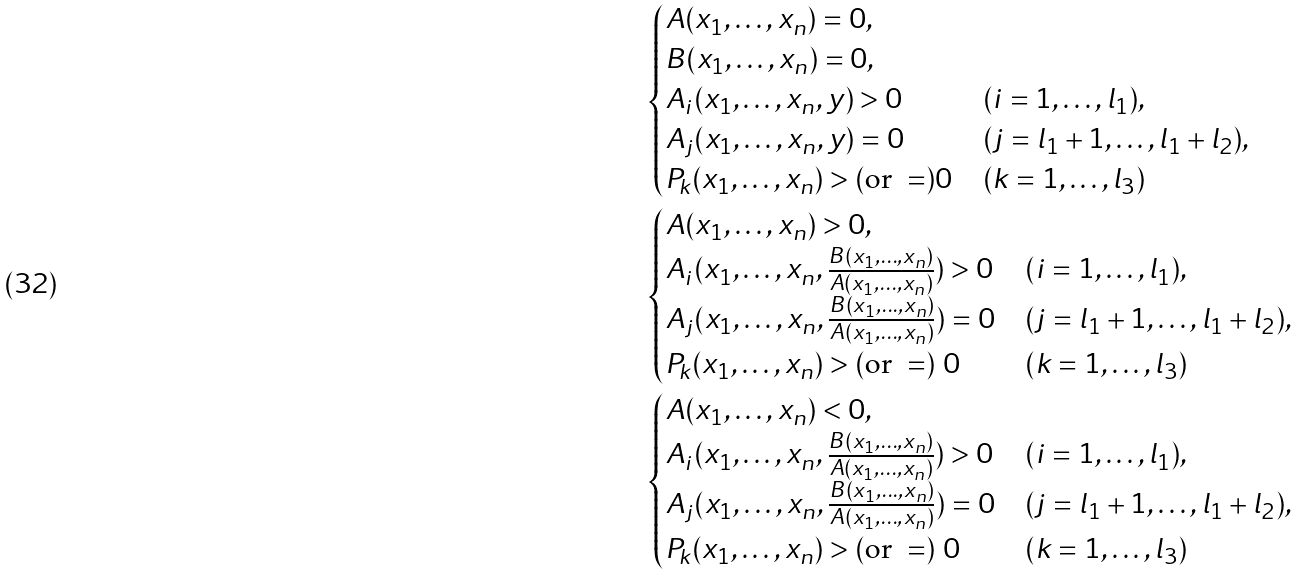Convert formula to latex. <formula><loc_0><loc_0><loc_500><loc_500>& \begin{cases} A ( x _ { 1 } , \dots , x _ { n } ) = 0 , & \\ B ( x _ { 1 } , \dots , x _ { n } ) = 0 , & \\ A _ { i } ( x _ { 1 } , \dots , x _ { n } , y ) > 0 & ( i = 1 , \dots , l _ { 1 } ) , \\ A _ { j } ( x _ { 1 } , \dots , x _ { n } , y ) = 0 & ( j = l _ { 1 } + 1 , \dots , l _ { 1 } + l _ { 2 } ) , \\ P _ { k } ( x _ { 1 } , \dots , x _ { n } ) > ( \text {or } = ) 0 & ( k = 1 , \dots , l _ { 3 } ) \end{cases} \\ & \begin{cases} A ( x _ { 1 } , \dots , x _ { n } ) > 0 , & \\ A _ { i } ( x _ { 1 } , \dots , x _ { n } , \frac { B ( x _ { 1 } , \dots , x _ { n } ) } { A ( x _ { 1 } , \dots , x _ { n } ) } ) > 0 & ( i = 1 , \dots , l _ { 1 } ) , \\ A _ { j } ( x _ { 1 } , \dots , x _ { n } , \frac { B ( x _ { 1 } , \dots , x _ { n } ) } { A ( x _ { 1 } , \dots , x _ { n } ) } ) = 0 & ( j = l _ { 1 } + 1 , \dots , l _ { 1 } + l _ { 2 } ) , \\ P _ { k } ( x _ { 1 } , \dots , x _ { n } ) > ( \text {or } = ) \ 0 & ( k = 1 , \dots , l _ { 3 } ) \\ \end{cases} \\ & \begin{cases} A ( x _ { 1 } , \dots , x _ { n } ) < 0 , & \\ A _ { i } ( x _ { 1 } , \dots , x _ { n } , \frac { B ( x _ { 1 } , \dots , x _ { n } ) } { A ( x _ { 1 } , \dots , x _ { n } ) } ) > 0 & ( i = 1 , \dots , l _ { 1 } ) , \\ A _ { j } ( x _ { 1 } , \dots , x _ { n } , \frac { B ( x _ { 1 } , \dots , x _ { n } ) } { A ( x _ { 1 } , \dots , x _ { n } ) } ) = 0 & ( j = l _ { 1 } + 1 , \dots , l _ { 1 } + l _ { 2 } ) , \\ P _ { k } ( x _ { 1 } , \dots , x _ { n } ) > ( \text {or } = ) \ 0 & ( k = 1 , \dots , l _ { 3 } ) \end{cases}</formula> 